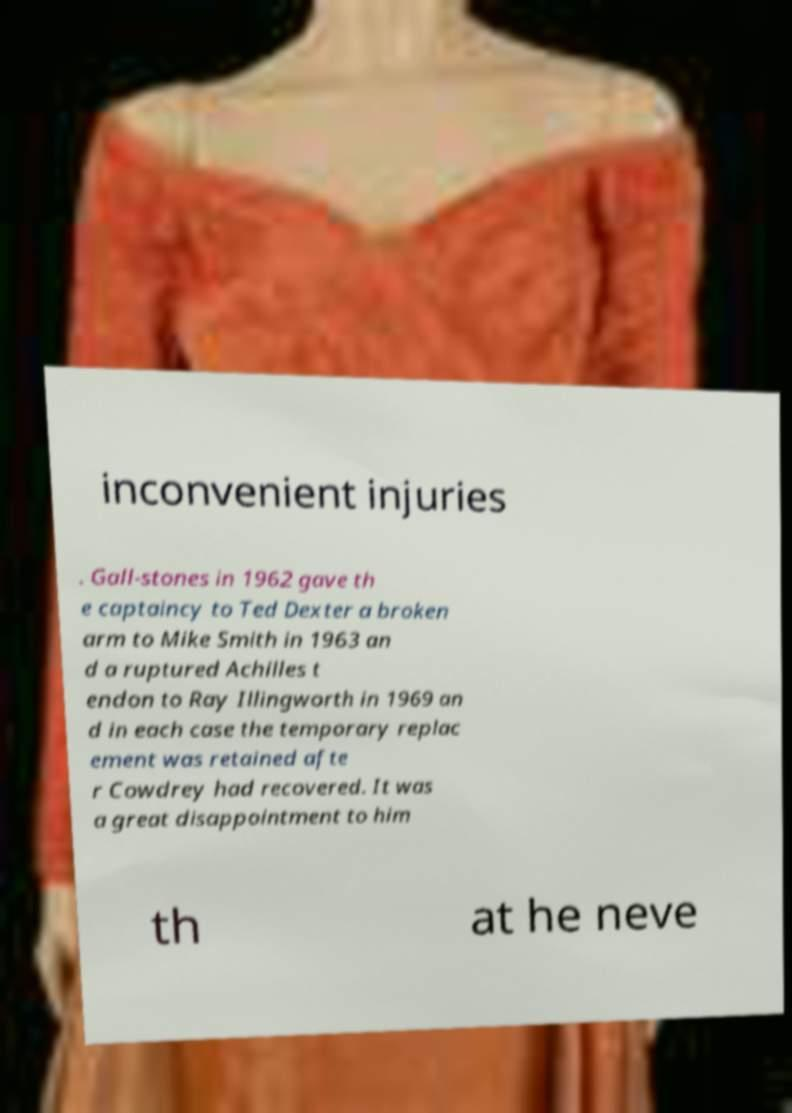Please read and relay the text visible in this image. What does it say? inconvenient injuries . Gall-stones in 1962 gave th e captaincy to Ted Dexter a broken arm to Mike Smith in 1963 an d a ruptured Achilles t endon to Ray Illingworth in 1969 an d in each case the temporary replac ement was retained afte r Cowdrey had recovered. It was a great disappointment to him th at he neve 